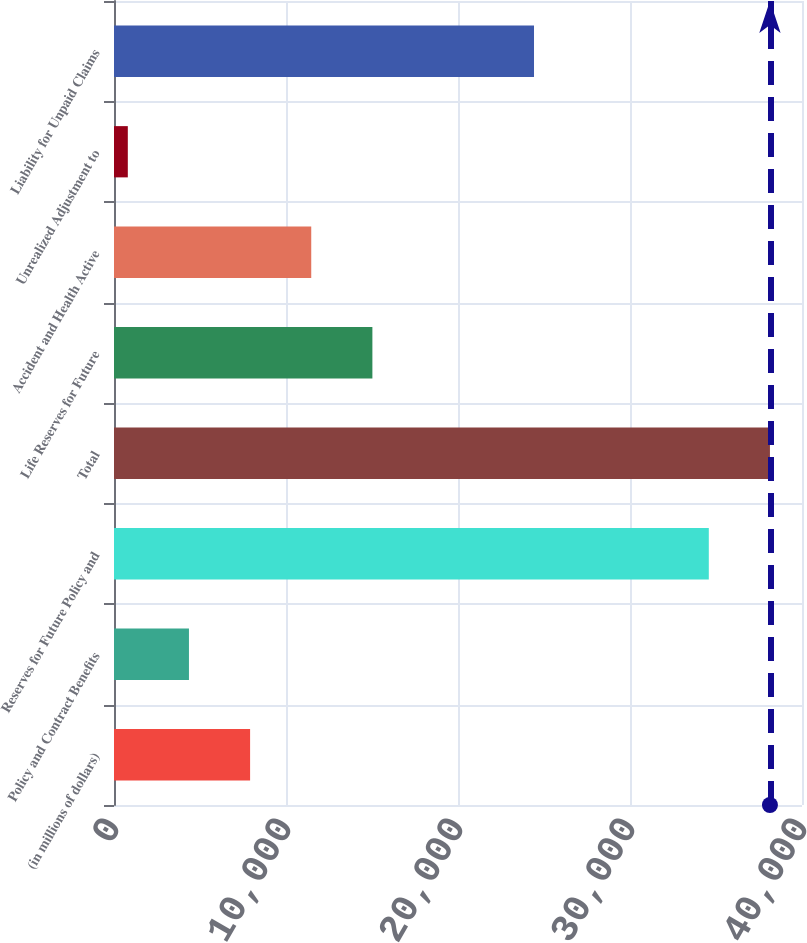<chart> <loc_0><loc_0><loc_500><loc_500><bar_chart><fcel>(in millions of dollars)<fcel>Policy and Contract Benefits<fcel>Reserves for Future Policy and<fcel>Total<fcel>Life Reserves for Future<fcel>Accident and Health Active<fcel>Unrealized Adjustment to<fcel>Liability for Unpaid Claims<nl><fcel>7912.68<fcel>4357.89<fcel>34581.5<fcel>38136.3<fcel>15022.3<fcel>11467.5<fcel>803.1<fcel>24419<nl></chart> 